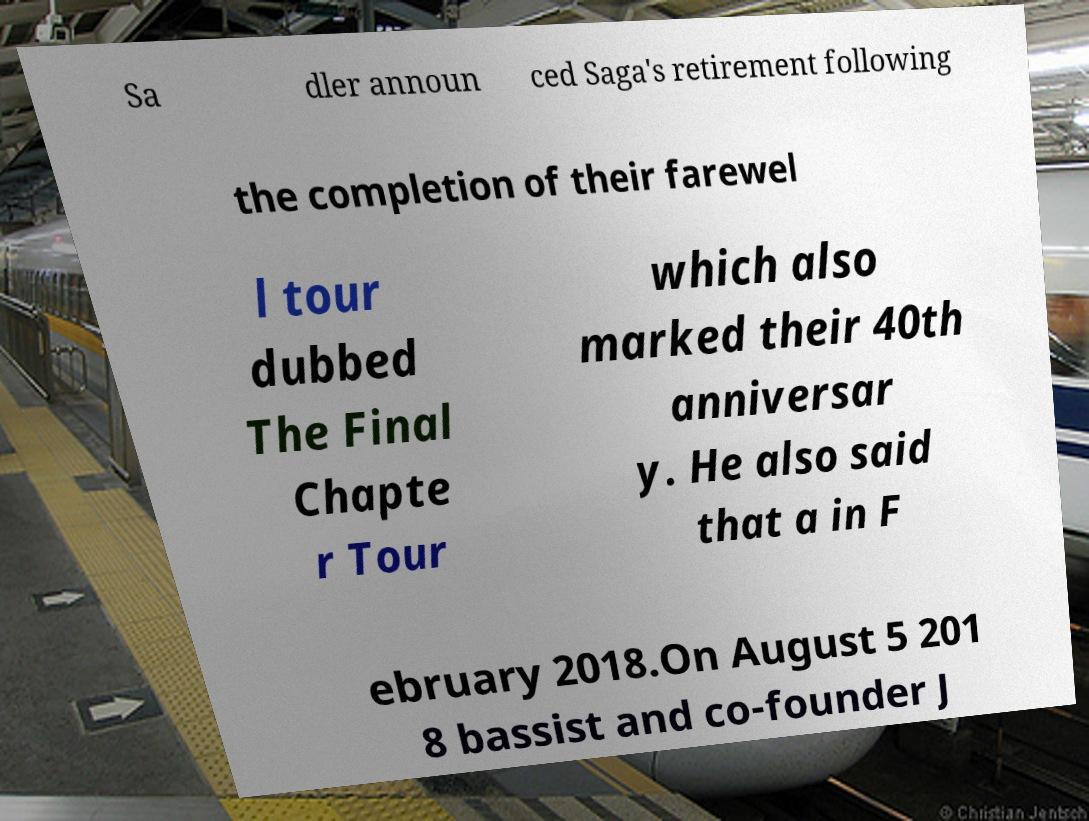Could you extract and type out the text from this image? Sa dler announ ced Saga's retirement following the completion of their farewel l tour dubbed The Final Chapte r Tour which also marked their 40th anniversar y. He also said that a in F ebruary 2018.On August 5 201 8 bassist and co-founder J 